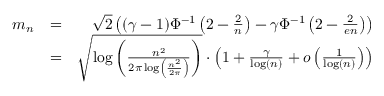<formula> <loc_0><loc_0><loc_500><loc_500>\begin{array} { r l r } { m _ { n } } & { = } & { \sqrt { 2 } \left ( ( \gamma - 1 ) \Phi ^ { - 1 } \left ( 2 - \frac { 2 } { n } \right ) - \gamma \Phi ^ { - 1 } \left ( 2 - \frac { 2 } { e n } \right ) \right ) } \\ & { = } & { \sqrt { \log \left ( \frac { n ^ { 2 } } { 2 \pi \log \left ( \frac { n ^ { 2 } } { 2 \pi } \right ) } \right ) } \cdot \left ( 1 + \frac { \gamma } { \log ( n ) } + \mathcal { o } \left ( \frac { 1 } { \log ( n ) } \right ) \right ) } \end{array}</formula> 